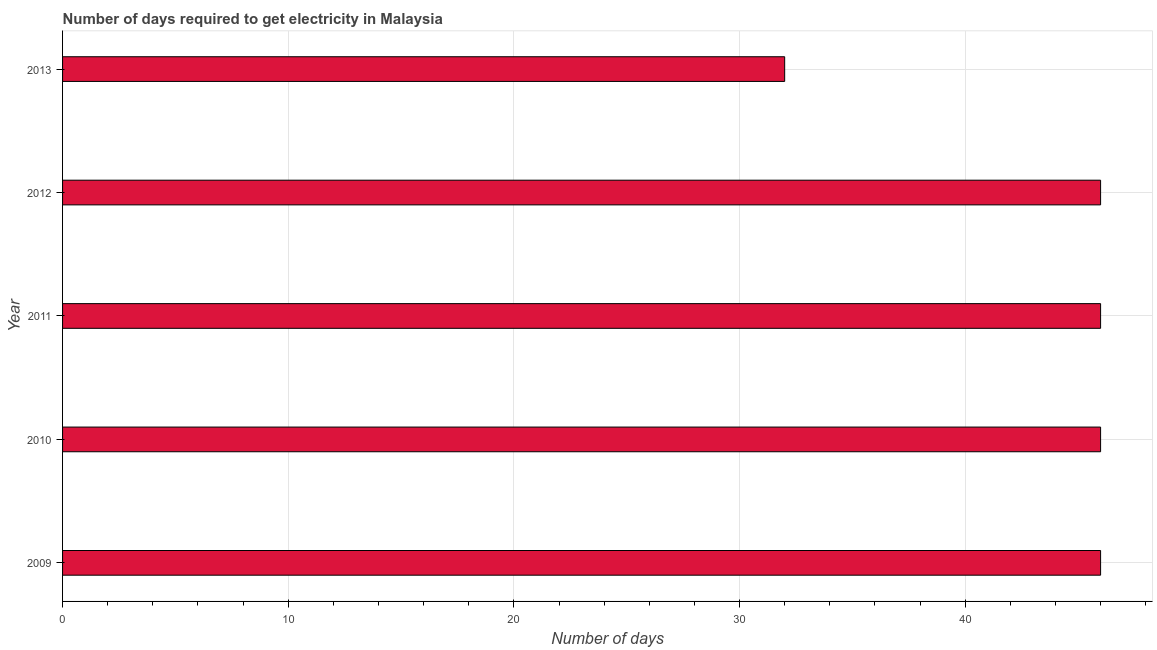Does the graph contain grids?
Offer a terse response. Yes. What is the title of the graph?
Keep it short and to the point. Number of days required to get electricity in Malaysia. What is the label or title of the X-axis?
Offer a terse response. Number of days. What is the label or title of the Y-axis?
Ensure brevity in your answer.  Year. What is the time to get electricity in 2010?
Keep it short and to the point. 46. Across all years, what is the maximum time to get electricity?
Your answer should be compact. 46. Across all years, what is the minimum time to get electricity?
Your answer should be compact. 32. In which year was the time to get electricity maximum?
Provide a short and direct response. 2009. In which year was the time to get electricity minimum?
Your answer should be compact. 2013. What is the sum of the time to get electricity?
Offer a terse response. 216. What is the median time to get electricity?
Offer a very short reply. 46. In how many years, is the time to get electricity greater than 4 ?
Give a very brief answer. 5. Do a majority of the years between 2011 and 2012 (inclusive) have time to get electricity greater than 40 ?
Provide a succinct answer. Yes. What is the ratio of the time to get electricity in 2010 to that in 2013?
Give a very brief answer. 1.44. Is the sum of the time to get electricity in 2010 and 2011 greater than the maximum time to get electricity across all years?
Offer a very short reply. Yes. What is the difference between the highest and the lowest time to get electricity?
Make the answer very short. 14. Are all the bars in the graph horizontal?
Offer a terse response. Yes. Are the values on the major ticks of X-axis written in scientific E-notation?
Your response must be concise. No. What is the Number of days in 2012?
Your answer should be very brief. 46. What is the difference between the Number of days in 2009 and 2011?
Provide a succinct answer. 0. What is the difference between the Number of days in 2009 and 2013?
Give a very brief answer. 14. What is the difference between the Number of days in 2010 and 2011?
Your answer should be compact. 0. What is the difference between the Number of days in 2010 and 2012?
Your answer should be compact. 0. What is the difference between the Number of days in 2010 and 2013?
Offer a very short reply. 14. What is the difference between the Number of days in 2011 and 2013?
Provide a short and direct response. 14. What is the difference between the Number of days in 2012 and 2013?
Provide a short and direct response. 14. What is the ratio of the Number of days in 2009 to that in 2011?
Make the answer very short. 1. What is the ratio of the Number of days in 2009 to that in 2012?
Give a very brief answer. 1. What is the ratio of the Number of days in 2009 to that in 2013?
Keep it short and to the point. 1.44. What is the ratio of the Number of days in 2010 to that in 2012?
Provide a short and direct response. 1. What is the ratio of the Number of days in 2010 to that in 2013?
Keep it short and to the point. 1.44. What is the ratio of the Number of days in 2011 to that in 2012?
Provide a succinct answer. 1. What is the ratio of the Number of days in 2011 to that in 2013?
Offer a terse response. 1.44. What is the ratio of the Number of days in 2012 to that in 2013?
Your answer should be very brief. 1.44. 